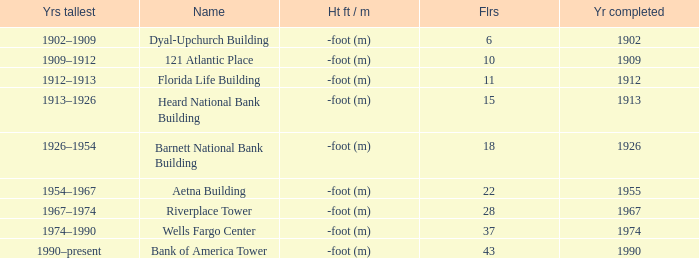How tall is the florida life building, completed before 1990? -foot (m). 